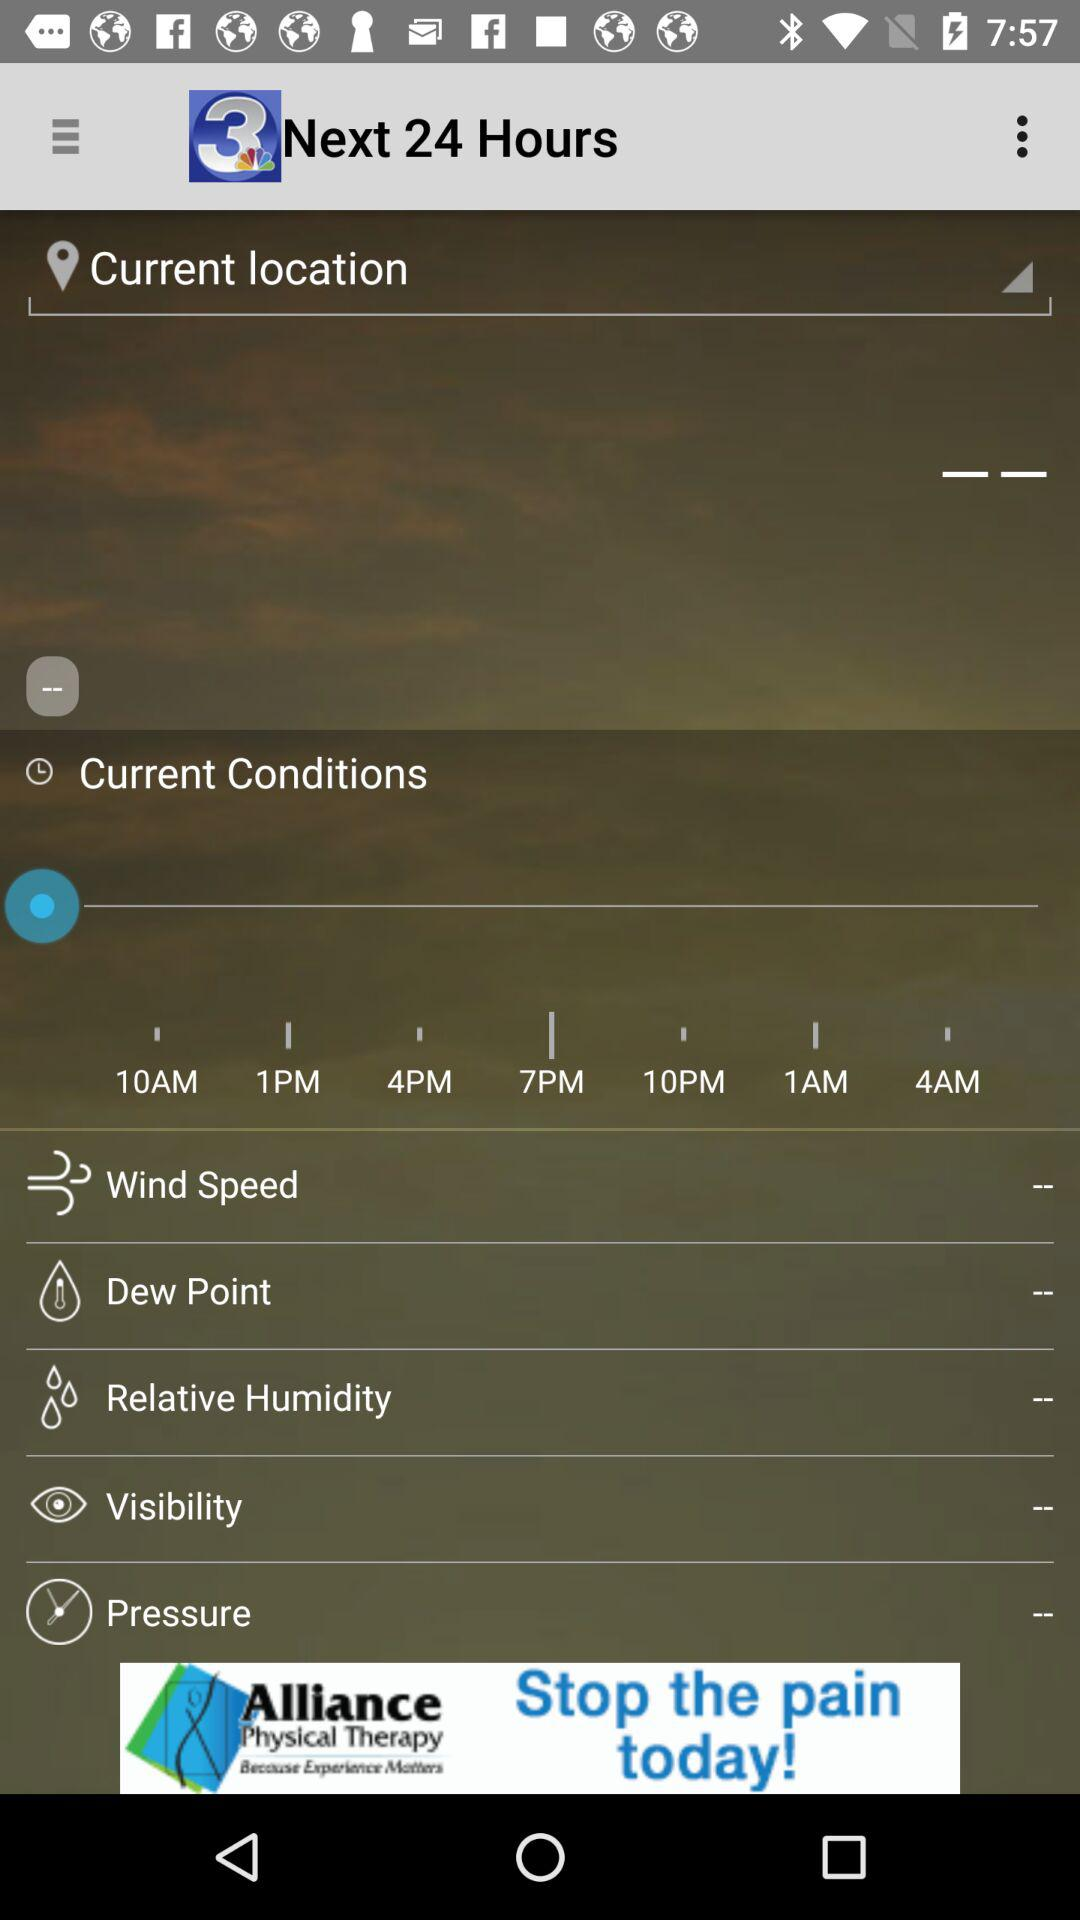What is the application name? The application name is "WSAV News - Savannah, GA". 